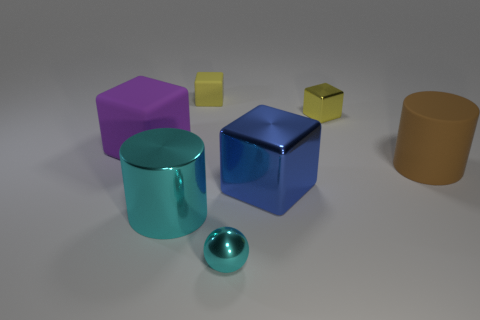Which object stands out the most in this arrangement, and why? The large blue cube stands out due to its vibrant color, central placement, and because it reflects light differently from the others, giving it a shinier appearance. Can you tell me about the lighting in this image? Where is it coming from? The lighting seems to be coming from above, as indicated by the shadows directly underneath the objects and the reflections on their upper surfaces. 